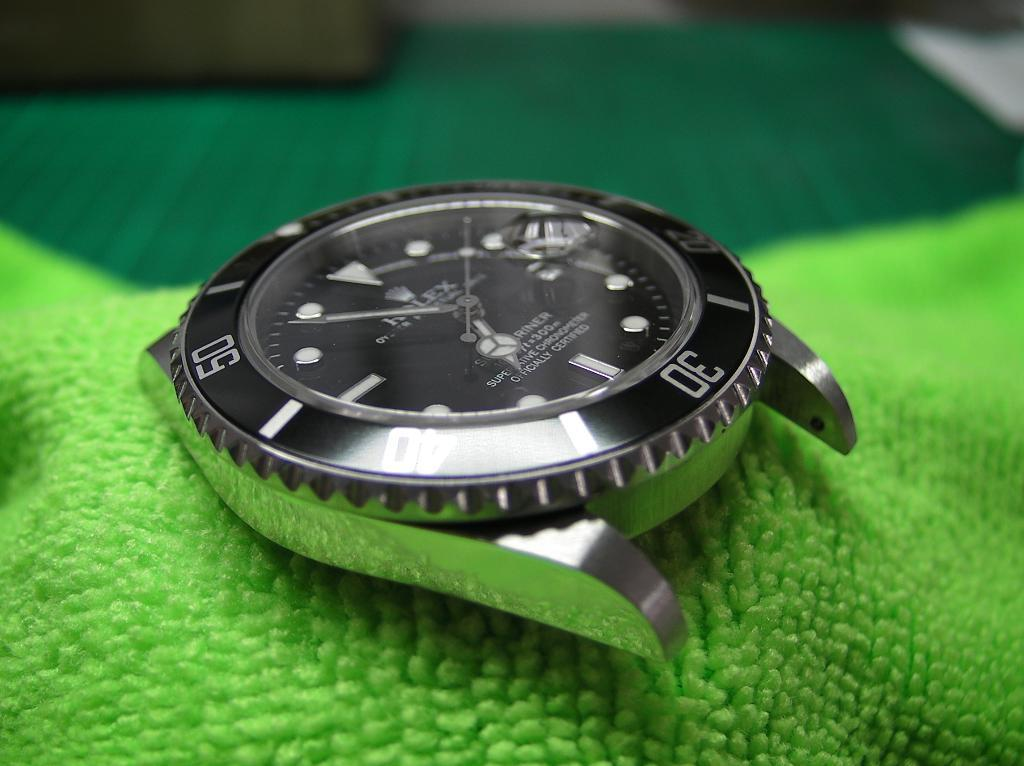What object can be seen in the image? There is a watch in the image. Can you describe the watch in more detail? Unfortunately, the image does not provide enough detail to describe the watch further. What type of houses can be seen in the background of the image? There is no background or houses present in the image; it only features a watch. What type of beef is being cooked in the image? There is no beef or cooking activity present in the image; it only features a watch. 